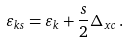Convert formula to latex. <formula><loc_0><loc_0><loc_500><loc_500>\varepsilon _ { k s } = \varepsilon _ { k } + \frac { s } { 2 } \Delta _ { x c } \, .</formula> 